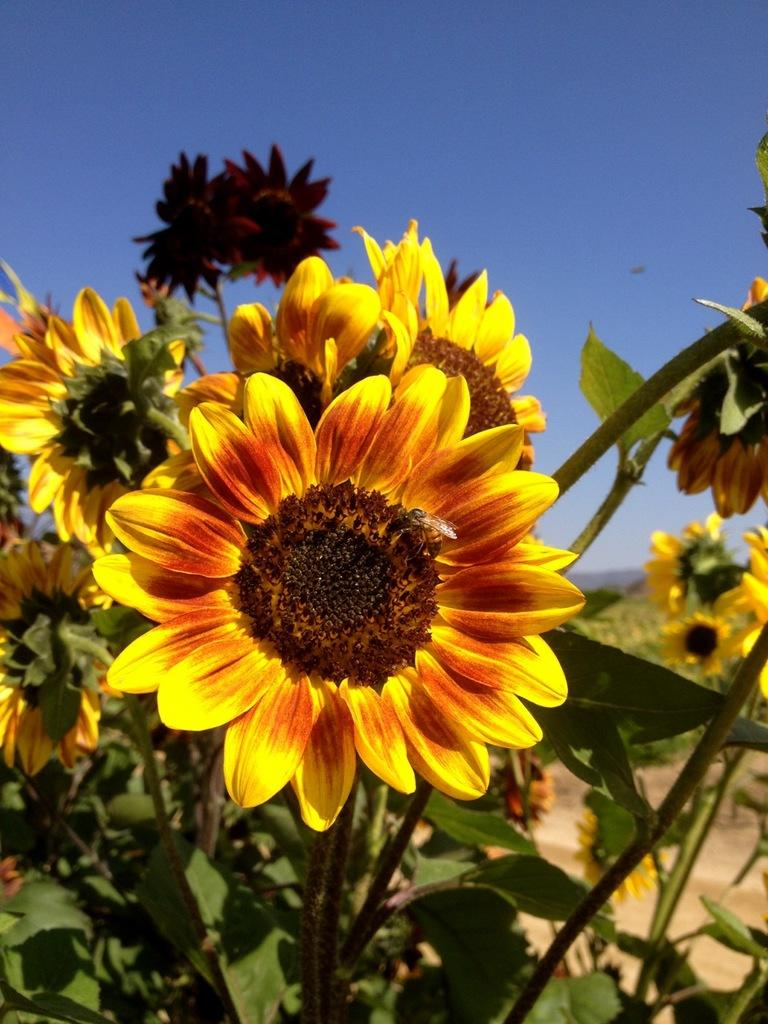What type of flowers are in the image? There are sunflowers in the image. What color are the leaves associated with the sunflowers? There are green leaves in the image. What can be seen in the background of the image? The sky is visible in the background of the image. Is there a pen being used to write on the sunflowers in the image? There is no pen or writing activity present in the image; it features sunflowers and green leaves. Can you see a van driving through the sunflowers in the image? There is no van or driving activity present in the image; it features sunflowers and green leaves against a sky background. 